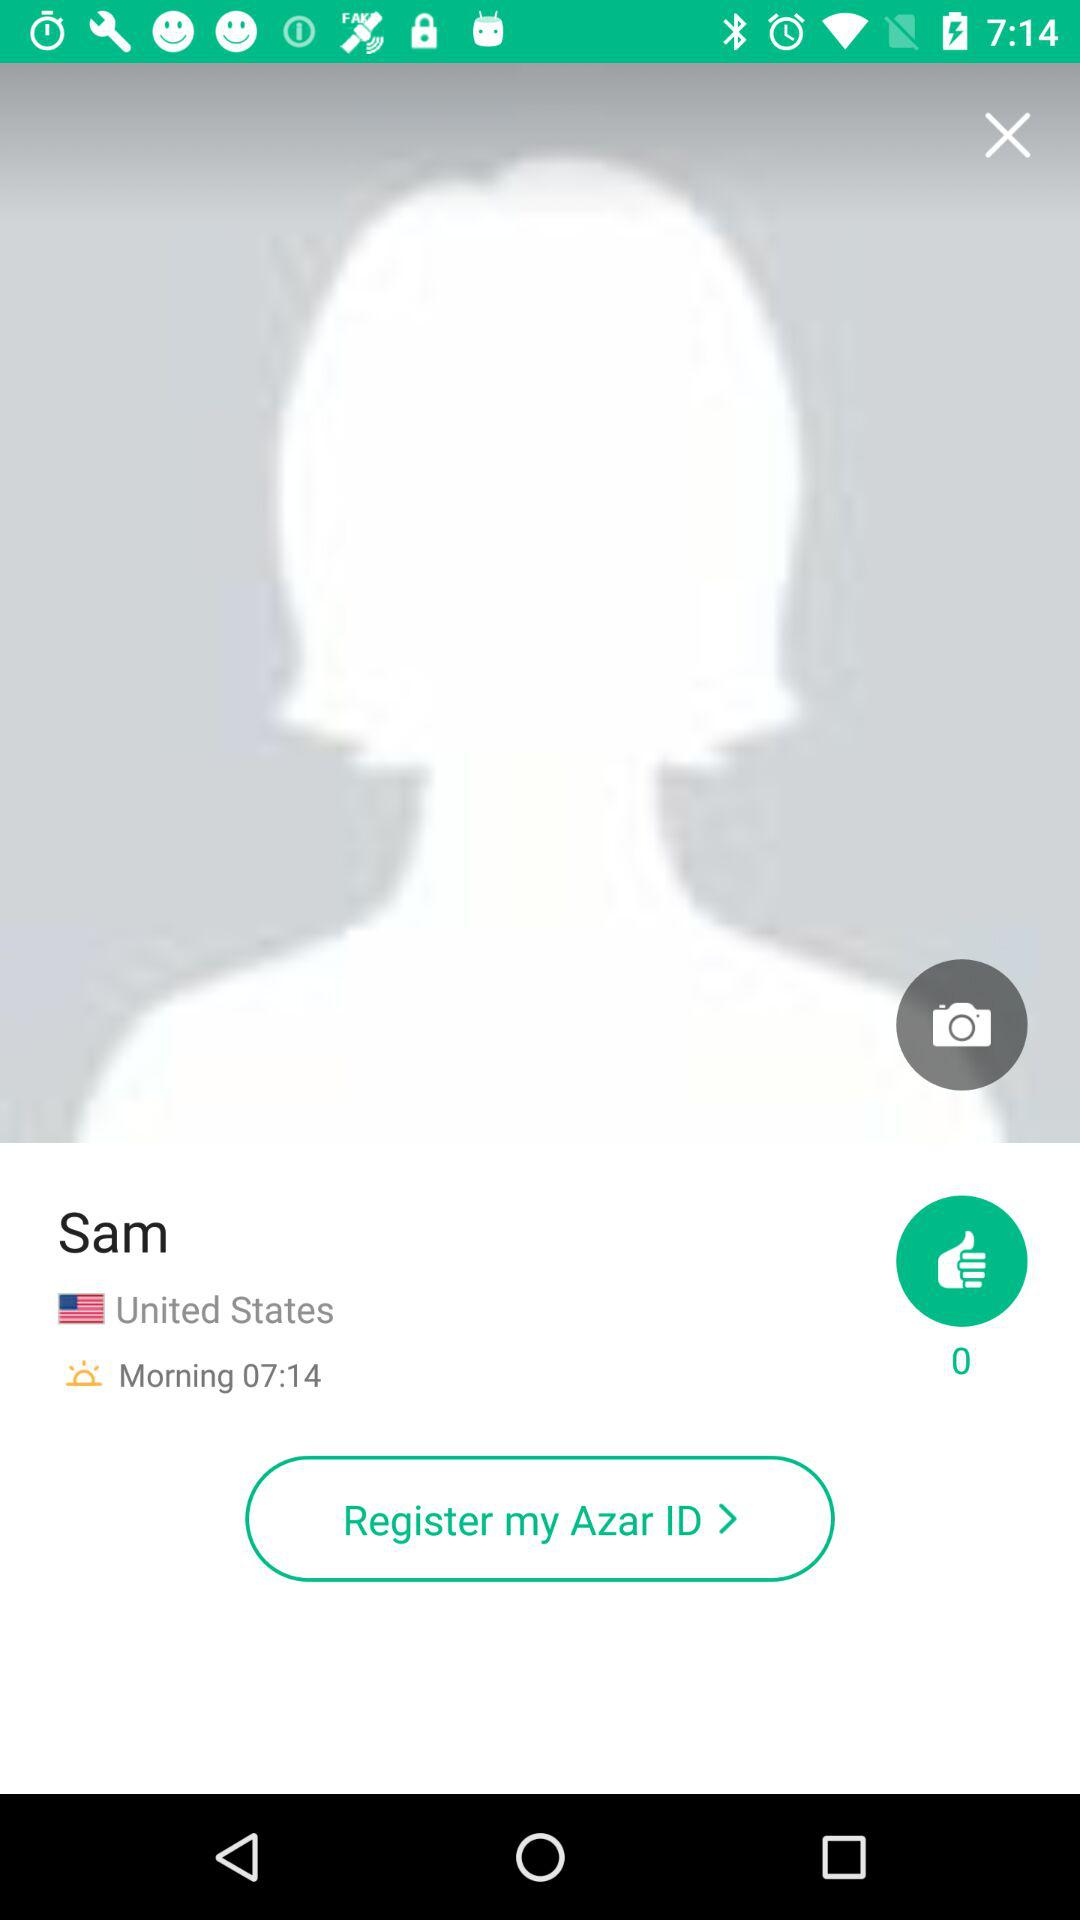How many images are available?
When the provided information is insufficient, respond with <no answer>. <no answer> 